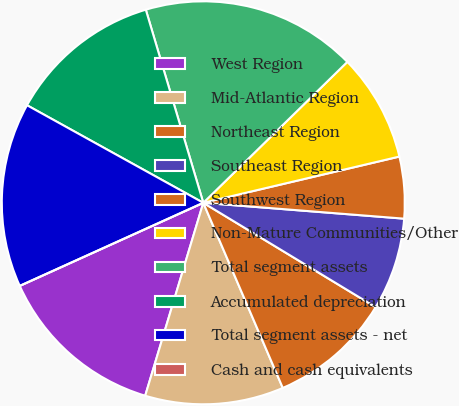<chart> <loc_0><loc_0><loc_500><loc_500><pie_chart><fcel>West Region<fcel>Mid-Atlantic Region<fcel>Northeast Region<fcel>Southeast Region<fcel>Southwest Region<fcel>Non-Mature Communities/Other<fcel>Total segment assets<fcel>Accumulated depreciation<fcel>Total segment assets - net<fcel>Cash and cash equivalents<nl><fcel>13.58%<fcel>11.11%<fcel>9.88%<fcel>7.41%<fcel>4.94%<fcel>8.64%<fcel>17.28%<fcel>12.35%<fcel>14.81%<fcel>0.0%<nl></chart> 